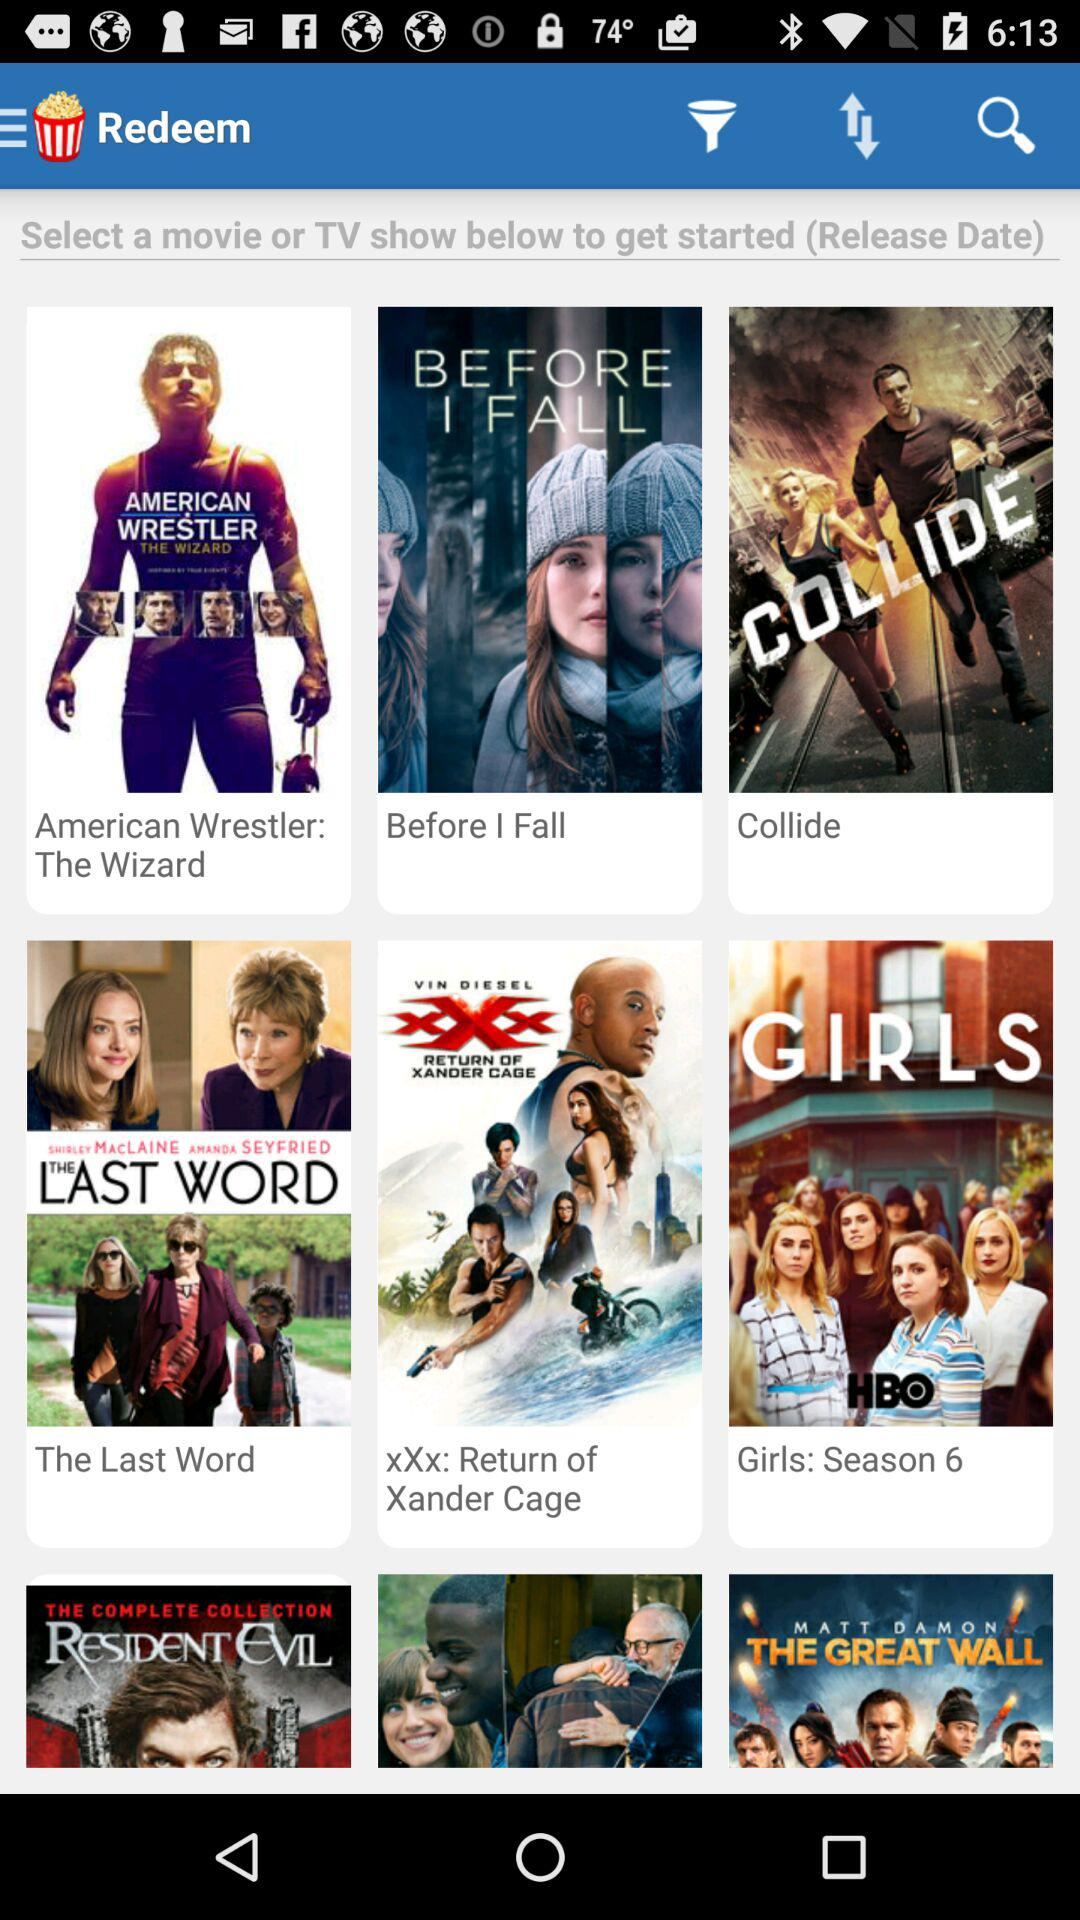Which season is available for the "Girls" series? The season available for the "Girls" series is "Season 6". 